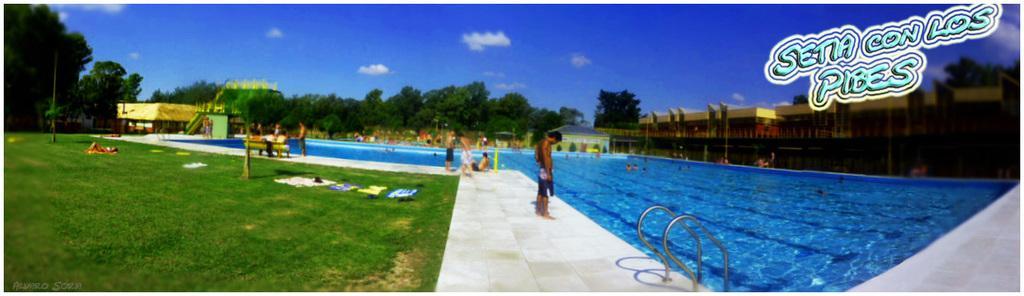In one or two sentences, can you explain what this image depicts? In this image few persons are on the floor. Left side a person is lying on the grassland having few clothes and trees. Left side there is a building. Middle of the image there is a swimming pool. Few persons are in water. Right side there are few buildings. Background there are few trees. Top of the image there is sky with some clouds. Right top there is some text. 